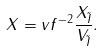Convert formula to latex. <formula><loc_0><loc_0><loc_500><loc_500>X = v f ^ { - 2 } { \frac { X _ { \tilde { I } } } { V _ { \tilde { I } } } . }</formula> 